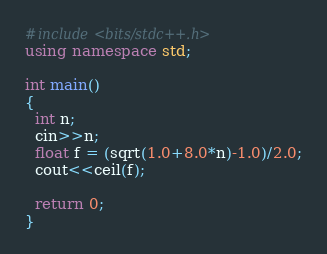<code> <loc_0><loc_0><loc_500><loc_500><_C++_>#include<bits/stdc++.h>
using namespace std;

int main()
{
  int n;
  cin>>n;
  float f = (sqrt(1.0+8.0*n)-1.0)/2.0;
  cout<<ceil(f);
  
  return 0;
}
</code> 